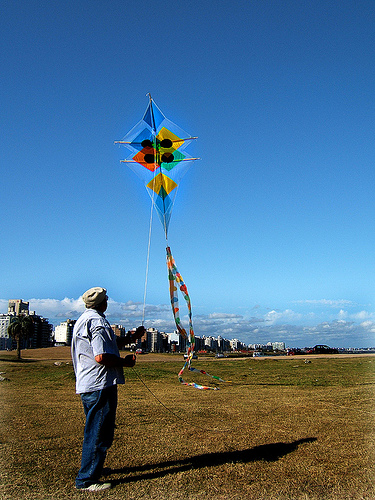What can you say about the attire of the person flying the kite? The individual is dressed casually, wearing a light-colored long sleeve shirt and darker pants, which are appropriate for a leisurely day outside. He also has a cap on, possibly for sun protection. The attire suggests comfort and ease, suitable for the recreational activity of kite flying. 